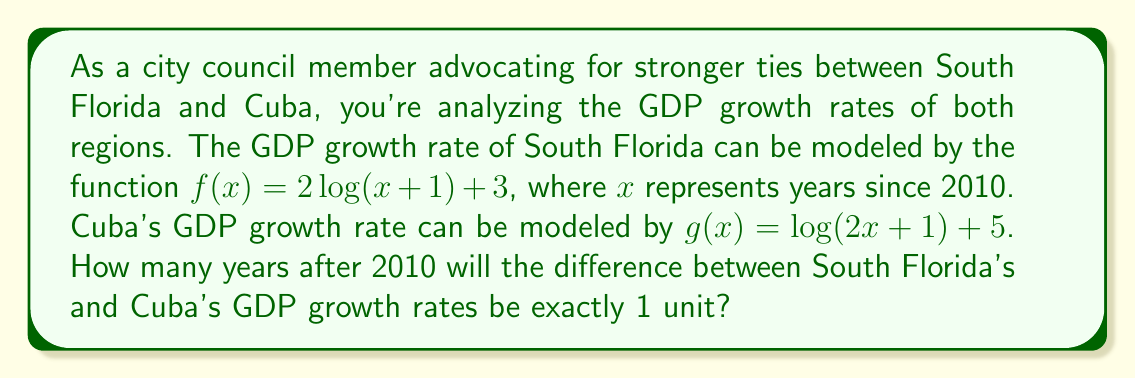Give your solution to this math problem. Let's approach this step-by-step:

1) We need to find $x$ where $f(x) - g(x) = 1$

2) Substitute the functions:
   $$(2\log(x+1) + 3) - (\log(2x+1) + 5) = 1$$

3) Simplify:
   $$2\log(x+1) - \log(2x+1) - 2 = 1$$

4) Combine like terms:
   $$2\log(x+1) - \log(2x+1) = 3$$

5) Use the properties of logarithms to combine the left side:
   $$\log\left(\frac{(x+1)^2}{2x+1}\right) = 3$$

6) Apply $e^x$ to both sides:
   $$\frac{(x+1)^2}{2x+1} = e^3$$

7) Multiply both sides by $(2x+1)$:
   $$(x+1)^2 = e^3(2x+1)$$

8) Expand:
   $$x^2 + 2x + 1 = 2e^3x + e^3$$

9) Rearrange to standard form:
   $$x^2 + (2-2e^3)x + (1-e^3) = 0$$

10) This is a quadratic equation. We can solve it using the quadratic formula:
    $$x = \frac{-(2-2e^3) \pm \sqrt{(2-2e^3)^2 - 4(1)(1-e^3)}}{2(1)}$$

11) Simplify and solve (using a calculator):
    $$x \approx 9.0645$$

12) Since we're dealing with years, we round to the nearest whole number.
Answer: 9 years after 2010 